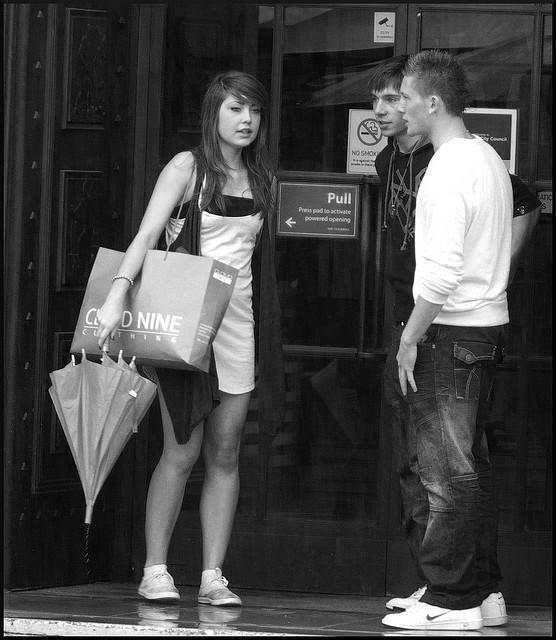What are the boys doing?
Indicate the correct response and explain using: 'Answer: answer
Rationale: rationale.'
Options: Interrogating her, being friendly, asking favor, being curious. Answer: being friendly.
Rationale: The boys are talking to the girl. 